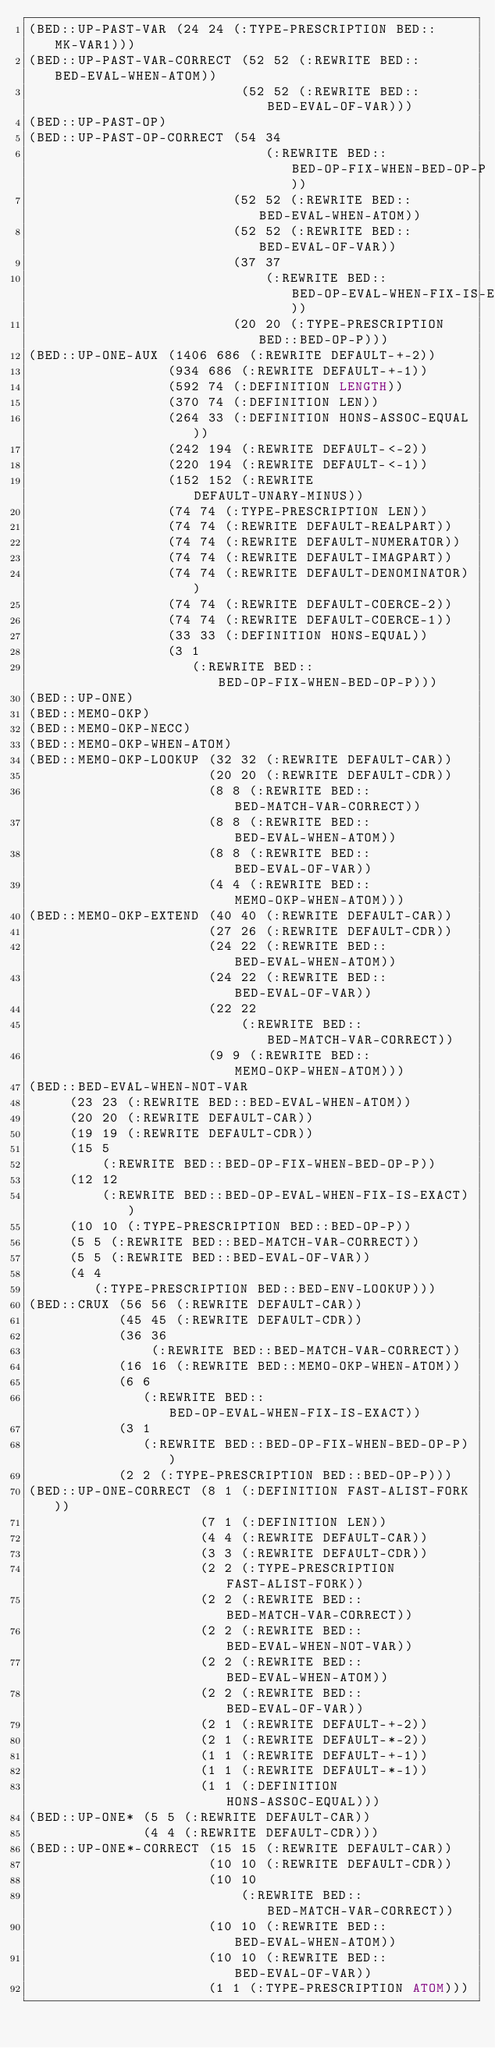<code> <loc_0><loc_0><loc_500><loc_500><_Lisp_>(BED::UP-PAST-VAR (24 24 (:TYPE-PRESCRIPTION BED::MK-VAR1)))
(BED::UP-PAST-VAR-CORRECT (52 52 (:REWRITE BED::BED-EVAL-WHEN-ATOM))
                          (52 52 (:REWRITE BED::BED-EVAL-OF-VAR)))
(BED::UP-PAST-OP)
(BED::UP-PAST-OP-CORRECT (54 34
                             (:REWRITE BED::BED-OP-FIX-WHEN-BED-OP-P))
                         (52 52 (:REWRITE BED::BED-EVAL-WHEN-ATOM))
                         (52 52 (:REWRITE BED::BED-EVAL-OF-VAR))
                         (37 37
                             (:REWRITE BED::BED-OP-EVAL-WHEN-FIX-IS-EXACT))
                         (20 20 (:TYPE-PRESCRIPTION BED::BED-OP-P)))
(BED::UP-ONE-AUX (1406 686 (:REWRITE DEFAULT-+-2))
                 (934 686 (:REWRITE DEFAULT-+-1))
                 (592 74 (:DEFINITION LENGTH))
                 (370 74 (:DEFINITION LEN))
                 (264 33 (:DEFINITION HONS-ASSOC-EQUAL))
                 (242 194 (:REWRITE DEFAULT-<-2))
                 (220 194 (:REWRITE DEFAULT-<-1))
                 (152 152 (:REWRITE DEFAULT-UNARY-MINUS))
                 (74 74 (:TYPE-PRESCRIPTION LEN))
                 (74 74 (:REWRITE DEFAULT-REALPART))
                 (74 74 (:REWRITE DEFAULT-NUMERATOR))
                 (74 74 (:REWRITE DEFAULT-IMAGPART))
                 (74 74 (:REWRITE DEFAULT-DENOMINATOR))
                 (74 74 (:REWRITE DEFAULT-COERCE-2))
                 (74 74 (:REWRITE DEFAULT-COERCE-1))
                 (33 33 (:DEFINITION HONS-EQUAL))
                 (3 1
                    (:REWRITE BED::BED-OP-FIX-WHEN-BED-OP-P)))
(BED::UP-ONE)
(BED::MEMO-OKP)
(BED::MEMO-OKP-NECC)
(BED::MEMO-OKP-WHEN-ATOM)
(BED::MEMO-OKP-LOOKUP (32 32 (:REWRITE DEFAULT-CAR))
                      (20 20 (:REWRITE DEFAULT-CDR))
                      (8 8 (:REWRITE BED::BED-MATCH-VAR-CORRECT))
                      (8 8 (:REWRITE BED::BED-EVAL-WHEN-ATOM))
                      (8 8 (:REWRITE BED::BED-EVAL-OF-VAR))
                      (4 4 (:REWRITE BED::MEMO-OKP-WHEN-ATOM)))
(BED::MEMO-OKP-EXTEND (40 40 (:REWRITE DEFAULT-CAR))
                      (27 26 (:REWRITE DEFAULT-CDR))
                      (24 22 (:REWRITE BED::BED-EVAL-WHEN-ATOM))
                      (24 22 (:REWRITE BED::BED-EVAL-OF-VAR))
                      (22 22
                          (:REWRITE BED::BED-MATCH-VAR-CORRECT))
                      (9 9 (:REWRITE BED::MEMO-OKP-WHEN-ATOM)))
(BED::BED-EVAL-WHEN-NOT-VAR
     (23 23 (:REWRITE BED::BED-EVAL-WHEN-ATOM))
     (20 20 (:REWRITE DEFAULT-CAR))
     (19 19 (:REWRITE DEFAULT-CDR))
     (15 5
         (:REWRITE BED::BED-OP-FIX-WHEN-BED-OP-P))
     (12 12
         (:REWRITE BED::BED-OP-EVAL-WHEN-FIX-IS-EXACT))
     (10 10 (:TYPE-PRESCRIPTION BED::BED-OP-P))
     (5 5 (:REWRITE BED::BED-MATCH-VAR-CORRECT))
     (5 5 (:REWRITE BED::BED-EVAL-OF-VAR))
     (4 4
        (:TYPE-PRESCRIPTION BED::BED-ENV-LOOKUP)))
(BED::CRUX (56 56 (:REWRITE DEFAULT-CAR))
           (45 45 (:REWRITE DEFAULT-CDR))
           (36 36
               (:REWRITE BED::BED-MATCH-VAR-CORRECT))
           (16 16 (:REWRITE BED::MEMO-OKP-WHEN-ATOM))
           (6 6
              (:REWRITE BED::BED-OP-EVAL-WHEN-FIX-IS-EXACT))
           (3 1
              (:REWRITE BED::BED-OP-FIX-WHEN-BED-OP-P))
           (2 2 (:TYPE-PRESCRIPTION BED::BED-OP-P)))
(BED::UP-ONE-CORRECT (8 1 (:DEFINITION FAST-ALIST-FORK))
                     (7 1 (:DEFINITION LEN))
                     (4 4 (:REWRITE DEFAULT-CAR))
                     (3 3 (:REWRITE DEFAULT-CDR))
                     (2 2 (:TYPE-PRESCRIPTION FAST-ALIST-FORK))
                     (2 2 (:REWRITE BED::BED-MATCH-VAR-CORRECT))
                     (2 2 (:REWRITE BED::BED-EVAL-WHEN-NOT-VAR))
                     (2 2 (:REWRITE BED::BED-EVAL-WHEN-ATOM))
                     (2 2 (:REWRITE BED::BED-EVAL-OF-VAR))
                     (2 1 (:REWRITE DEFAULT-+-2))
                     (2 1 (:REWRITE DEFAULT-*-2))
                     (1 1 (:REWRITE DEFAULT-+-1))
                     (1 1 (:REWRITE DEFAULT-*-1))
                     (1 1 (:DEFINITION HONS-ASSOC-EQUAL)))
(BED::UP-ONE* (5 5 (:REWRITE DEFAULT-CAR))
              (4 4 (:REWRITE DEFAULT-CDR)))
(BED::UP-ONE*-CORRECT (15 15 (:REWRITE DEFAULT-CAR))
                      (10 10 (:REWRITE DEFAULT-CDR))
                      (10 10
                          (:REWRITE BED::BED-MATCH-VAR-CORRECT))
                      (10 10 (:REWRITE BED::BED-EVAL-WHEN-ATOM))
                      (10 10 (:REWRITE BED::BED-EVAL-OF-VAR))
                      (1 1 (:TYPE-PRESCRIPTION ATOM)))
</code> 